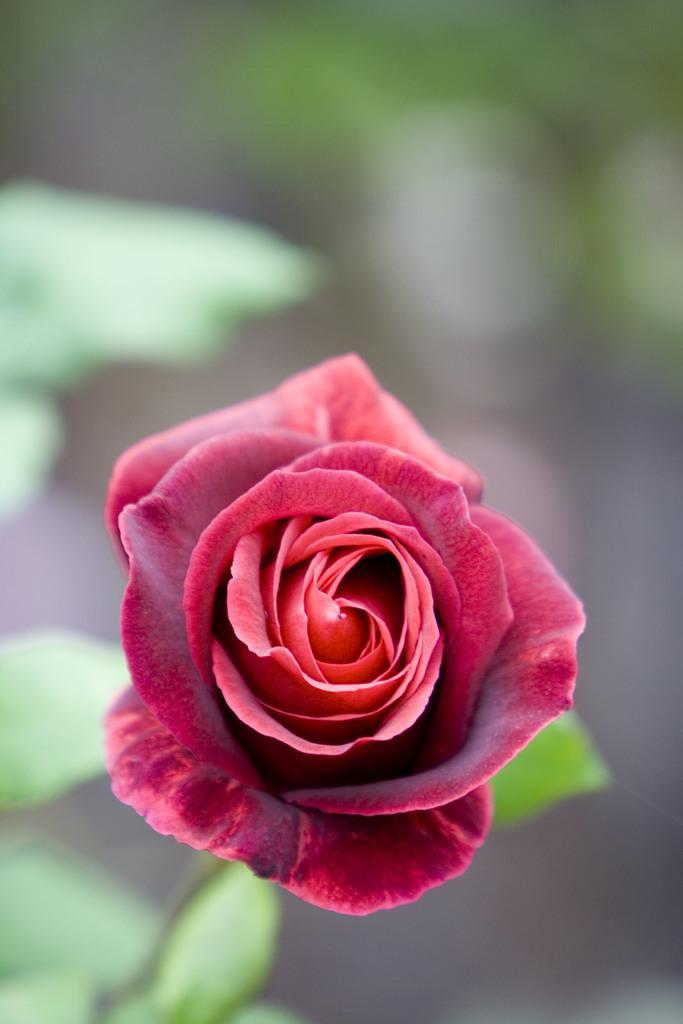Could you give a brief overview of what you see in this image? Background portion of the picture is blurry and we can see a red rose and green leaves. 